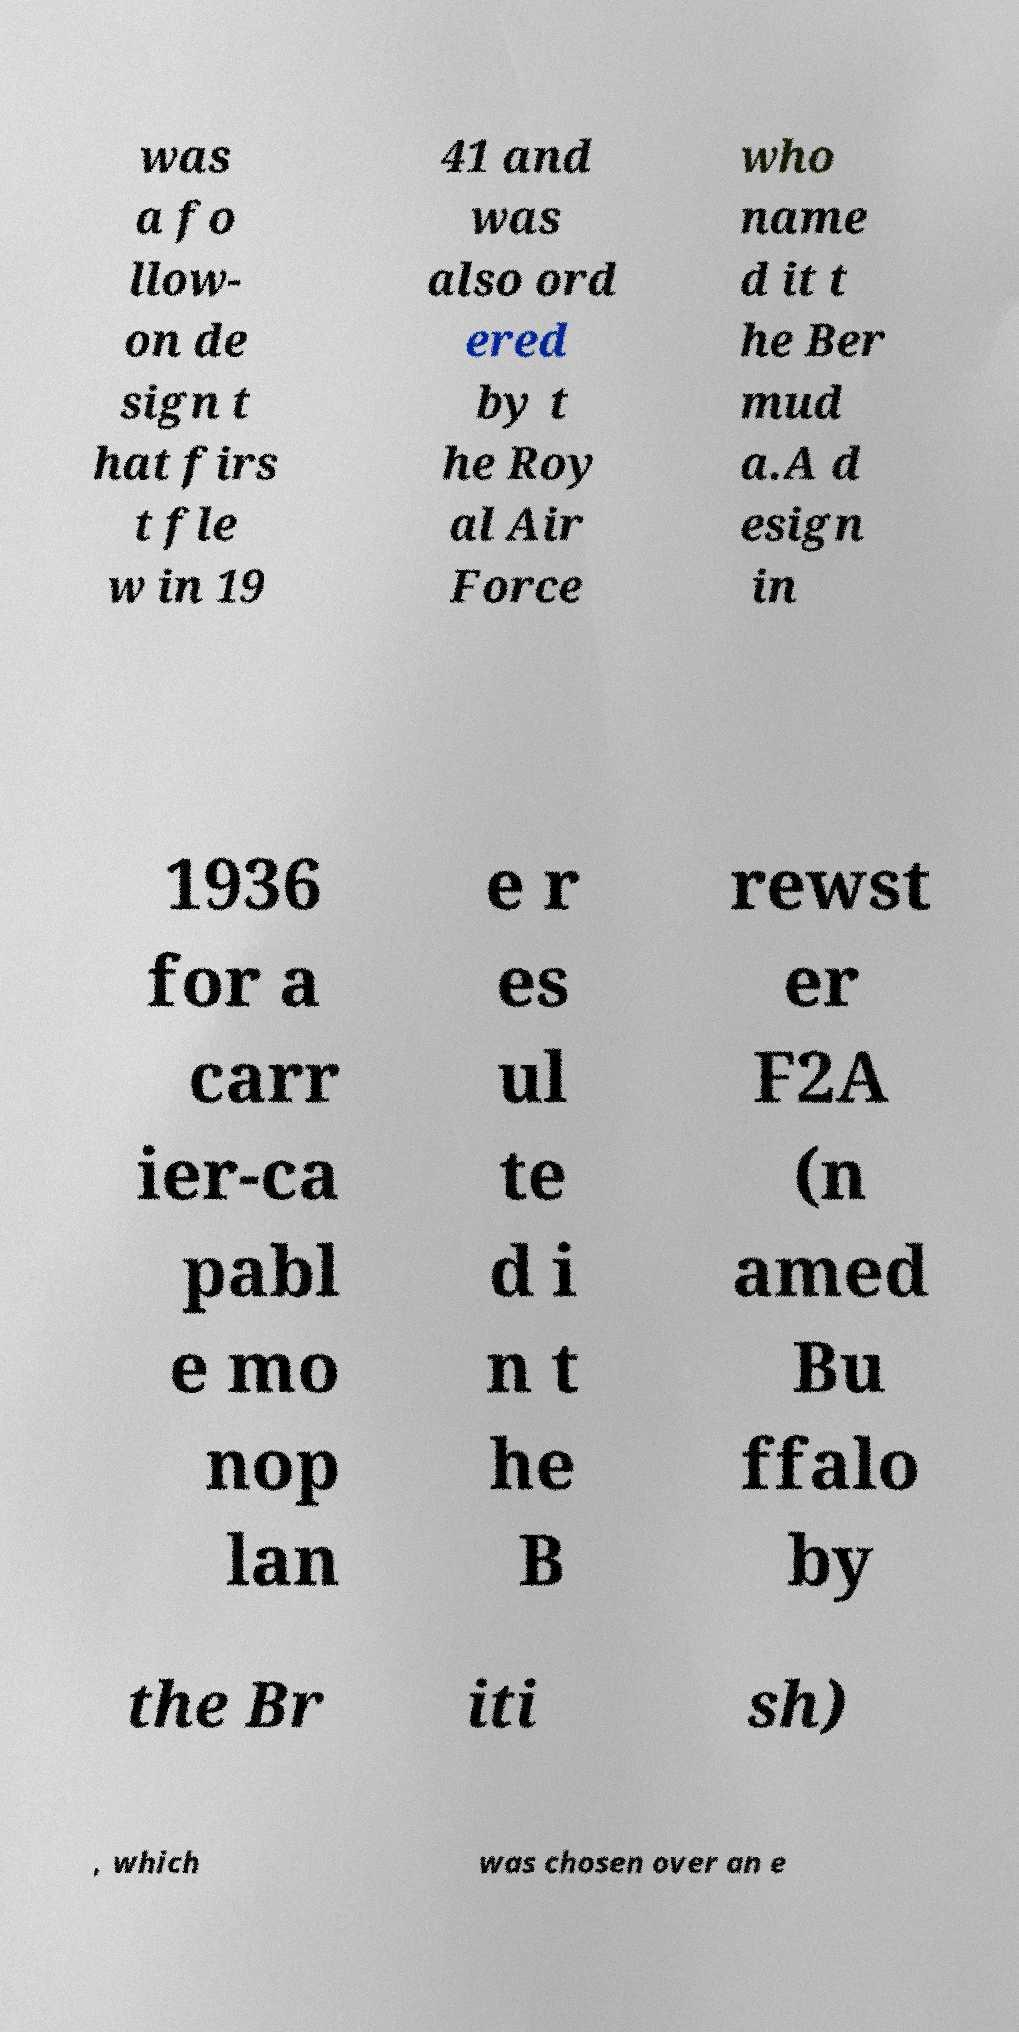Can you read and provide the text displayed in the image?This photo seems to have some interesting text. Can you extract and type it out for me? was a fo llow- on de sign t hat firs t fle w in 19 41 and was also ord ered by t he Roy al Air Force who name d it t he Ber mud a.A d esign in 1936 for a carr ier-ca pabl e mo nop lan e r es ul te d i n t he B rewst er F2A (n amed Bu ffalo by the Br iti sh) , which was chosen over an e 